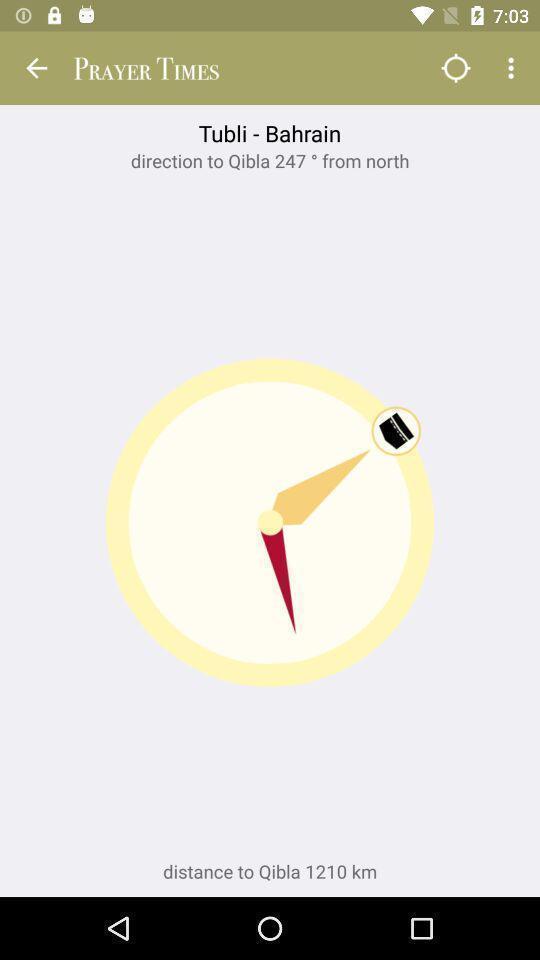What can you discern from this picture? Page for adding prayer timings. 